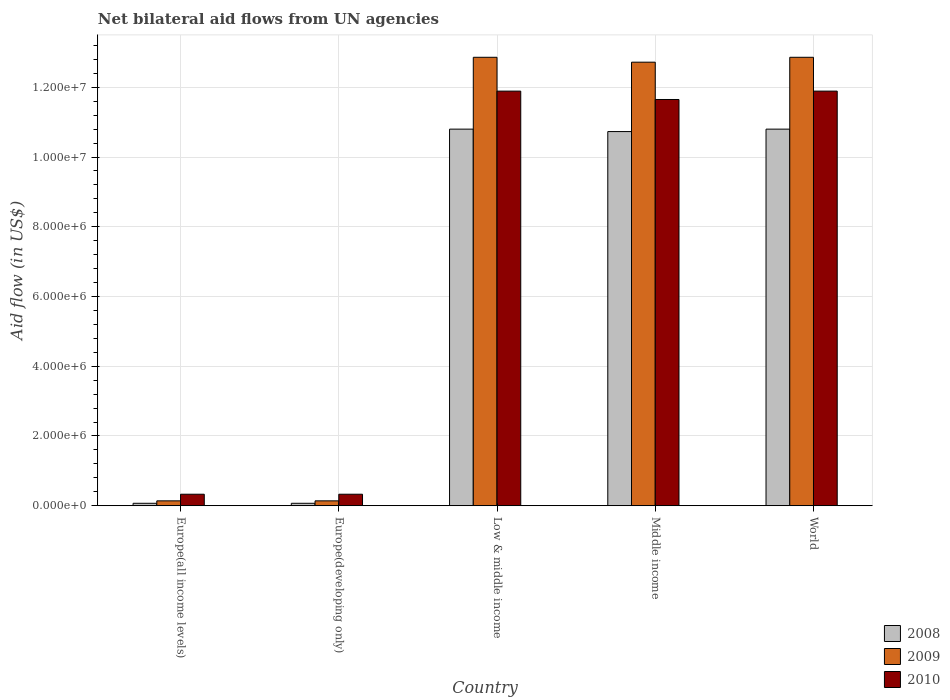How many different coloured bars are there?
Your response must be concise. 3. How many groups of bars are there?
Offer a terse response. 5. Are the number of bars per tick equal to the number of legend labels?
Keep it short and to the point. Yes. How many bars are there on the 1st tick from the left?
Keep it short and to the point. 3. What is the net bilateral aid flow in 2010 in Europe(all income levels)?
Ensure brevity in your answer.  3.30e+05. Across all countries, what is the maximum net bilateral aid flow in 2009?
Offer a terse response. 1.29e+07. In which country was the net bilateral aid flow in 2010 maximum?
Your answer should be compact. Low & middle income. In which country was the net bilateral aid flow in 2009 minimum?
Provide a short and direct response. Europe(all income levels). What is the total net bilateral aid flow in 2010 in the graph?
Keep it short and to the point. 3.61e+07. What is the difference between the net bilateral aid flow in 2010 in Low & middle income and the net bilateral aid flow in 2008 in World?
Make the answer very short. 1.09e+06. What is the average net bilateral aid flow in 2009 per country?
Provide a succinct answer. 7.74e+06. In how many countries, is the net bilateral aid flow in 2009 greater than 12400000 US$?
Ensure brevity in your answer.  3. What is the ratio of the net bilateral aid flow in 2009 in Europe(all income levels) to that in World?
Give a very brief answer. 0.01. Is the net bilateral aid flow in 2009 in Low & middle income less than that in World?
Give a very brief answer. No. What is the difference between the highest and the lowest net bilateral aid flow in 2008?
Ensure brevity in your answer.  1.07e+07. In how many countries, is the net bilateral aid flow in 2009 greater than the average net bilateral aid flow in 2009 taken over all countries?
Offer a terse response. 3. Is the sum of the net bilateral aid flow in 2008 in Middle income and World greater than the maximum net bilateral aid flow in 2009 across all countries?
Make the answer very short. Yes. How many bars are there?
Make the answer very short. 15. Are all the bars in the graph horizontal?
Keep it short and to the point. No. What is the difference between two consecutive major ticks on the Y-axis?
Your answer should be very brief. 2.00e+06. What is the title of the graph?
Your answer should be compact. Net bilateral aid flows from UN agencies. Does "2007" appear as one of the legend labels in the graph?
Offer a terse response. No. What is the label or title of the Y-axis?
Your answer should be very brief. Aid flow (in US$). What is the Aid flow (in US$) in 2009 in Europe(all income levels)?
Provide a succinct answer. 1.40e+05. What is the Aid flow (in US$) of 2010 in Europe(all income levels)?
Provide a succinct answer. 3.30e+05. What is the Aid flow (in US$) of 2008 in Europe(developing only)?
Offer a very short reply. 7.00e+04. What is the Aid flow (in US$) of 2009 in Europe(developing only)?
Provide a succinct answer. 1.40e+05. What is the Aid flow (in US$) in 2010 in Europe(developing only)?
Offer a terse response. 3.30e+05. What is the Aid flow (in US$) of 2008 in Low & middle income?
Offer a terse response. 1.08e+07. What is the Aid flow (in US$) of 2009 in Low & middle income?
Keep it short and to the point. 1.29e+07. What is the Aid flow (in US$) in 2010 in Low & middle income?
Give a very brief answer. 1.19e+07. What is the Aid flow (in US$) in 2008 in Middle income?
Your answer should be very brief. 1.07e+07. What is the Aid flow (in US$) of 2009 in Middle income?
Give a very brief answer. 1.27e+07. What is the Aid flow (in US$) of 2010 in Middle income?
Provide a short and direct response. 1.16e+07. What is the Aid flow (in US$) of 2008 in World?
Make the answer very short. 1.08e+07. What is the Aid flow (in US$) in 2009 in World?
Give a very brief answer. 1.29e+07. What is the Aid flow (in US$) of 2010 in World?
Keep it short and to the point. 1.19e+07. Across all countries, what is the maximum Aid flow (in US$) in 2008?
Give a very brief answer. 1.08e+07. Across all countries, what is the maximum Aid flow (in US$) in 2009?
Ensure brevity in your answer.  1.29e+07. Across all countries, what is the maximum Aid flow (in US$) in 2010?
Your answer should be very brief. 1.19e+07. Across all countries, what is the minimum Aid flow (in US$) of 2008?
Make the answer very short. 7.00e+04. Across all countries, what is the minimum Aid flow (in US$) in 2009?
Ensure brevity in your answer.  1.40e+05. What is the total Aid flow (in US$) in 2008 in the graph?
Ensure brevity in your answer.  3.25e+07. What is the total Aid flow (in US$) in 2009 in the graph?
Ensure brevity in your answer.  3.87e+07. What is the total Aid flow (in US$) in 2010 in the graph?
Give a very brief answer. 3.61e+07. What is the difference between the Aid flow (in US$) of 2009 in Europe(all income levels) and that in Europe(developing only)?
Your answer should be very brief. 0. What is the difference between the Aid flow (in US$) of 2010 in Europe(all income levels) and that in Europe(developing only)?
Offer a terse response. 0. What is the difference between the Aid flow (in US$) in 2008 in Europe(all income levels) and that in Low & middle income?
Your answer should be compact. -1.07e+07. What is the difference between the Aid flow (in US$) in 2009 in Europe(all income levels) and that in Low & middle income?
Offer a very short reply. -1.27e+07. What is the difference between the Aid flow (in US$) of 2010 in Europe(all income levels) and that in Low & middle income?
Provide a short and direct response. -1.16e+07. What is the difference between the Aid flow (in US$) in 2008 in Europe(all income levels) and that in Middle income?
Give a very brief answer. -1.07e+07. What is the difference between the Aid flow (in US$) in 2009 in Europe(all income levels) and that in Middle income?
Your response must be concise. -1.26e+07. What is the difference between the Aid flow (in US$) in 2010 in Europe(all income levels) and that in Middle income?
Offer a very short reply. -1.13e+07. What is the difference between the Aid flow (in US$) in 2008 in Europe(all income levels) and that in World?
Give a very brief answer. -1.07e+07. What is the difference between the Aid flow (in US$) in 2009 in Europe(all income levels) and that in World?
Provide a short and direct response. -1.27e+07. What is the difference between the Aid flow (in US$) of 2010 in Europe(all income levels) and that in World?
Make the answer very short. -1.16e+07. What is the difference between the Aid flow (in US$) in 2008 in Europe(developing only) and that in Low & middle income?
Ensure brevity in your answer.  -1.07e+07. What is the difference between the Aid flow (in US$) of 2009 in Europe(developing only) and that in Low & middle income?
Ensure brevity in your answer.  -1.27e+07. What is the difference between the Aid flow (in US$) in 2010 in Europe(developing only) and that in Low & middle income?
Give a very brief answer. -1.16e+07. What is the difference between the Aid flow (in US$) in 2008 in Europe(developing only) and that in Middle income?
Your answer should be very brief. -1.07e+07. What is the difference between the Aid flow (in US$) of 2009 in Europe(developing only) and that in Middle income?
Your answer should be compact. -1.26e+07. What is the difference between the Aid flow (in US$) of 2010 in Europe(developing only) and that in Middle income?
Ensure brevity in your answer.  -1.13e+07. What is the difference between the Aid flow (in US$) in 2008 in Europe(developing only) and that in World?
Your answer should be compact. -1.07e+07. What is the difference between the Aid flow (in US$) in 2009 in Europe(developing only) and that in World?
Offer a very short reply. -1.27e+07. What is the difference between the Aid flow (in US$) in 2010 in Europe(developing only) and that in World?
Ensure brevity in your answer.  -1.16e+07. What is the difference between the Aid flow (in US$) of 2008 in Low & middle income and that in Middle income?
Offer a terse response. 7.00e+04. What is the difference between the Aid flow (in US$) in 2010 in Low & middle income and that in Middle income?
Offer a terse response. 2.40e+05. What is the difference between the Aid flow (in US$) of 2010 in Low & middle income and that in World?
Your answer should be compact. 0. What is the difference between the Aid flow (in US$) in 2008 in Middle income and that in World?
Offer a very short reply. -7.00e+04. What is the difference between the Aid flow (in US$) of 2009 in Middle income and that in World?
Your answer should be very brief. -1.40e+05. What is the difference between the Aid flow (in US$) in 2010 in Middle income and that in World?
Provide a succinct answer. -2.40e+05. What is the difference between the Aid flow (in US$) in 2009 in Europe(all income levels) and the Aid flow (in US$) in 2010 in Europe(developing only)?
Make the answer very short. -1.90e+05. What is the difference between the Aid flow (in US$) of 2008 in Europe(all income levels) and the Aid flow (in US$) of 2009 in Low & middle income?
Your response must be concise. -1.28e+07. What is the difference between the Aid flow (in US$) in 2008 in Europe(all income levels) and the Aid flow (in US$) in 2010 in Low & middle income?
Your answer should be very brief. -1.18e+07. What is the difference between the Aid flow (in US$) of 2009 in Europe(all income levels) and the Aid flow (in US$) of 2010 in Low & middle income?
Your answer should be very brief. -1.18e+07. What is the difference between the Aid flow (in US$) of 2008 in Europe(all income levels) and the Aid flow (in US$) of 2009 in Middle income?
Offer a very short reply. -1.26e+07. What is the difference between the Aid flow (in US$) of 2008 in Europe(all income levels) and the Aid flow (in US$) of 2010 in Middle income?
Provide a succinct answer. -1.16e+07. What is the difference between the Aid flow (in US$) in 2009 in Europe(all income levels) and the Aid flow (in US$) in 2010 in Middle income?
Your answer should be very brief. -1.15e+07. What is the difference between the Aid flow (in US$) of 2008 in Europe(all income levels) and the Aid flow (in US$) of 2009 in World?
Keep it short and to the point. -1.28e+07. What is the difference between the Aid flow (in US$) of 2008 in Europe(all income levels) and the Aid flow (in US$) of 2010 in World?
Ensure brevity in your answer.  -1.18e+07. What is the difference between the Aid flow (in US$) in 2009 in Europe(all income levels) and the Aid flow (in US$) in 2010 in World?
Your response must be concise. -1.18e+07. What is the difference between the Aid flow (in US$) in 2008 in Europe(developing only) and the Aid flow (in US$) in 2009 in Low & middle income?
Give a very brief answer. -1.28e+07. What is the difference between the Aid flow (in US$) in 2008 in Europe(developing only) and the Aid flow (in US$) in 2010 in Low & middle income?
Ensure brevity in your answer.  -1.18e+07. What is the difference between the Aid flow (in US$) in 2009 in Europe(developing only) and the Aid flow (in US$) in 2010 in Low & middle income?
Ensure brevity in your answer.  -1.18e+07. What is the difference between the Aid flow (in US$) of 2008 in Europe(developing only) and the Aid flow (in US$) of 2009 in Middle income?
Provide a succinct answer. -1.26e+07. What is the difference between the Aid flow (in US$) in 2008 in Europe(developing only) and the Aid flow (in US$) in 2010 in Middle income?
Your answer should be compact. -1.16e+07. What is the difference between the Aid flow (in US$) in 2009 in Europe(developing only) and the Aid flow (in US$) in 2010 in Middle income?
Provide a short and direct response. -1.15e+07. What is the difference between the Aid flow (in US$) in 2008 in Europe(developing only) and the Aid flow (in US$) in 2009 in World?
Keep it short and to the point. -1.28e+07. What is the difference between the Aid flow (in US$) in 2008 in Europe(developing only) and the Aid flow (in US$) in 2010 in World?
Your answer should be very brief. -1.18e+07. What is the difference between the Aid flow (in US$) in 2009 in Europe(developing only) and the Aid flow (in US$) in 2010 in World?
Your answer should be very brief. -1.18e+07. What is the difference between the Aid flow (in US$) of 2008 in Low & middle income and the Aid flow (in US$) of 2009 in Middle income?
Offer a terse response. -1.92e+06. What is the difference between the Aid flow (in US$) in 2008 in Low & middle income and the Aid flow (in US$) in 2010 in Middle income?
Offer a very short reply. -8.50e+05. What is the difference between the Aid flow (in US$) in 2009 in Low & middle income and the Aid flow (in US$) in 2010 in Middle income?
Give a very brief answer. 1.21e+06. What is the difference between the Aid flow (in US$) of 2008 in Low & middle income and the Aid flow (in US$) of 2009 in World?
Your answer should be compact. -2.06e+06. What is the difference between the Aid flow (in US$) in 2008 in Low & middle income and the Aid flow (in US$) in 2010 in World?
Keep it short and to the point. -1.09e+06. What is the difference between the Aid flow (in US$) in 2009 in Low & middle income and the Aid flow (in US$) in 2010 in World?
Offer a terse response. 9.70e+05. What is the difference between the Aid flow (in US$) in 2008 in Middle income and the Aid flow (in US$) in 2009 in World?
Your answer should be very brief. -2.13e+06. What is the difference between the Aid flow (in US$) of 2008 in Middle income and the Aid flow (in US$) of 2010 in World?
Your response must be concise. -1.16e+06. What is the difference between the Aid flow (in US$) in 2009 in Middle income and the Aid flow (in US$) in 2010 in World?
Offer a very short reply. 8.30e+05. What is the average Aid flow (in US$) in 2008 per country?
Your answer should be compact. 6.49e+06. What is the average Aid flow (in US$) of 2009 per country?
Your response must be concise. 7.74e+06. What is the average Aid flow (in US$) in 2010 per country?
Keep it short and to the point. 7.22e+06. What is the difference between the Aid flow (in US$) in 2008 and Aid flow (in US$) in 2009 in Europe(all income levels)?
Keep it short and to the point. -7.00e+04. What is the difference between the Aid flow (in US$) in 2008 and Aid flow (in US$) in 2010 in Europe(all income levels)?
Give a very brief answer. -2.60e+05. What is the difference between the Aid flow (in US$) in 2008 and Aid flow (in US$) in 2010 in Europe(developing only)?
Your answer should be compact. -2.60e+05. What is the difference between the Aid flow (in US$) of 2009 and Aid flow (in US$) of 2010 in Europe(developing only)?
Your answer should be very brief. -1.90e+05. What is the difference between the Aid flow (in US$) of 2008 and Aid flow (in US$) of 2009 in Low & middle income?
Your answer should be very brief. -2.06e+06. What is the difference between the Aid flow (in US$) of 2008 and Aid flow (in US$) of 2010 in Low & middle income?
Provide a succinct answer. -1.09e+06. What is the difference between the Aid flow (in US$) in 2009 and Aid flow (in US$) in 2010 in Low & middle income?
Your answer should be compact. 9.70e+05. What is the difference between the Aid flow (in US$) in 2008 and Aid flow (in US$) in 2009 in Middle income?
Give a very brief answer. -1.99e+06. What is the difference between the Aid flow (in US$) in 2008 and Aid flow (in US$) in 2010 in Middle income?
Ensure brevity in your answer.  -9.20e+05. What is the difference between the Aid flow (in US$) in 2009 and Aid flow (in US$) in 2010 in Middle income?
Your response must be concise. 1.07e+06. What is the difference between the Aid flow (in US$) in 2008 and Aid flow (in US$) in 2009 in World?
Your answer should be compact. -2.06e+06. What is the difference between the Aid flow (in US$) in 2008 and Aid flow (in US$) in 2010 in World?
Make the answer very short. -1.09e+06. What is the difference between the Aid flow (in US$) of 2009 and Aid flow (in US$) of 2010 in World?
Your response must be concise. 9.70e+05. What is the ratio of the Aid flow (in US$) of 2009 in Europe(all income levels) to that in Europe(developing only)?
Offer a very short reply. 1. What is the ratio of the Aid flow (in US$) in 2010 in Europe(all income levels) to that in Europe(developing only)?
Your response must be concise. 1. What is the ratio of the Aid flow (in US$) of 2008 in Europe(all income levels) to that in Low & middle income?
Your answer should be compact. 0.01. What is the ratio of the Aid flow (in US$) of 2009 in Europe(all income levels) to that in Low & middle income?
Ensure brevity in your answer.  0.01. What is the ratio of the Aid flow (in US$) of 2010 in Europe(all income levels) to that in Low & middle income?
Your answer should be compact. 0.03. What is the ratio of the Aid flow (in US$) in 2008 in Europe(all income levels) to that in Middle income?
Your answer should be compact. 0.01. What is the ratio of the Aid flow (in US$) in 2009 in Europe(all income levels) to that in Middle income?
Your answer should be very brief. 0.01. What is the ratio of the Aid flow (in US$) of 2010 in Europe(all income levels) to that in Middle income?
Keep it short and to the point. 0.03. What is the ratio of the Aid flow (in US$) in 2008 in Europe(all income levels) to that in World?
Make the answer very short. 0.01. What is the ratio of the Aid flow (in US$) of 2009 in Europe(all income levels) to that in World?
Your answer should be very brief. 0.01. What is the ratio of the Aid flow (in US$) of 2010 in Europe(all income levels) to that in World?
Offer a very short reply. 0.03. What is the ratio of the Aid flow (in US$) in 2008 in Europe(developing only) to that in Low & middle income?
Make the answer very short. 0.01. What is the ratio of the Aid flow (in US$) of 2009 in Europe(developing only) to that in Low & middle income?
Keep it short and to the point. 0.01. What is the ratio of the Aid flow (in US$) in 2010 in Europe(developing only) to that in Low & middle income?
Your answer should be compact. 0.03. What is the ratio of the Aid flow (in US$) in 2008 in Europe(developing only) to that in Middle income?
Provide a short and direct response. 0.01. What is the ratio of the Aid flow (in US$) of 2009 in Europe(developing only) to that in Middle income?
Give a very brief answer. 0.01. What is the ratio of the Aid flow (in US$) in 2010 in Europe(developing only) to that in Middle income?
Make the answer very short. 0.03. What is the ratio of the Aid flow (in US$) of 2008 in Europe(developing only) to that in World?
Give a very brief answer. 0.01. What is the ratio of the Aid flow (in US$) in 2009 in Europe(developing only) to that in World?
Your response must be concise. 0.01. What is the ratio of the Aid flow (in US$) of 2010 in Europe(developing only) to that in World?
Offer a very short reply. 0.03. What is the ratio of the Aid flow (in US$) of 2008 in Low & middle income to that in Middle income?
Provide a succinct answer. 1.01. What is the ratio of the Aid flow (in US$) in 2010 in Low & middle income to that in Middle income?
Keep it short and to the point. 1.02. What is the ratio of the Aid flow (in US$) in 2009 in Low & middle income to that in World?
Provide a short and direct response. 1. What is the ratio of the Aid flow (in US$) in 2010 in Low & middle income to that in World?
Your answer should be very brief. 1. What is the ratio of the Aid flow (in US$) of 2009 in Middle income to that in World?
Provide a succinct answer. 0.99. What is the ratio of the Aid flow (in US$) in 2010 in Middle income to that in World?
Your response must be concise. 0.98. What is the difference between the highest and the second highest Aid flow (in US$) of 2008?
Offer a very short reply. 0. What is the difference between the highest and the second highest Aid flow (in US$) of 2010?
Your response must be concise. 0. What is the difference between the highest and the lowest Aid flow (in US$) in 2008?
Offer a terse response. 1.07e+07. What is the difference between the highest and the lowest Aid flow (in US$) in 2009?
Offer a very short reply. 1.27e+07. What is the difference between the highest and the lowest Aid flow (in US$) of 2010?
Your response must be concise. 1.16e+07. 